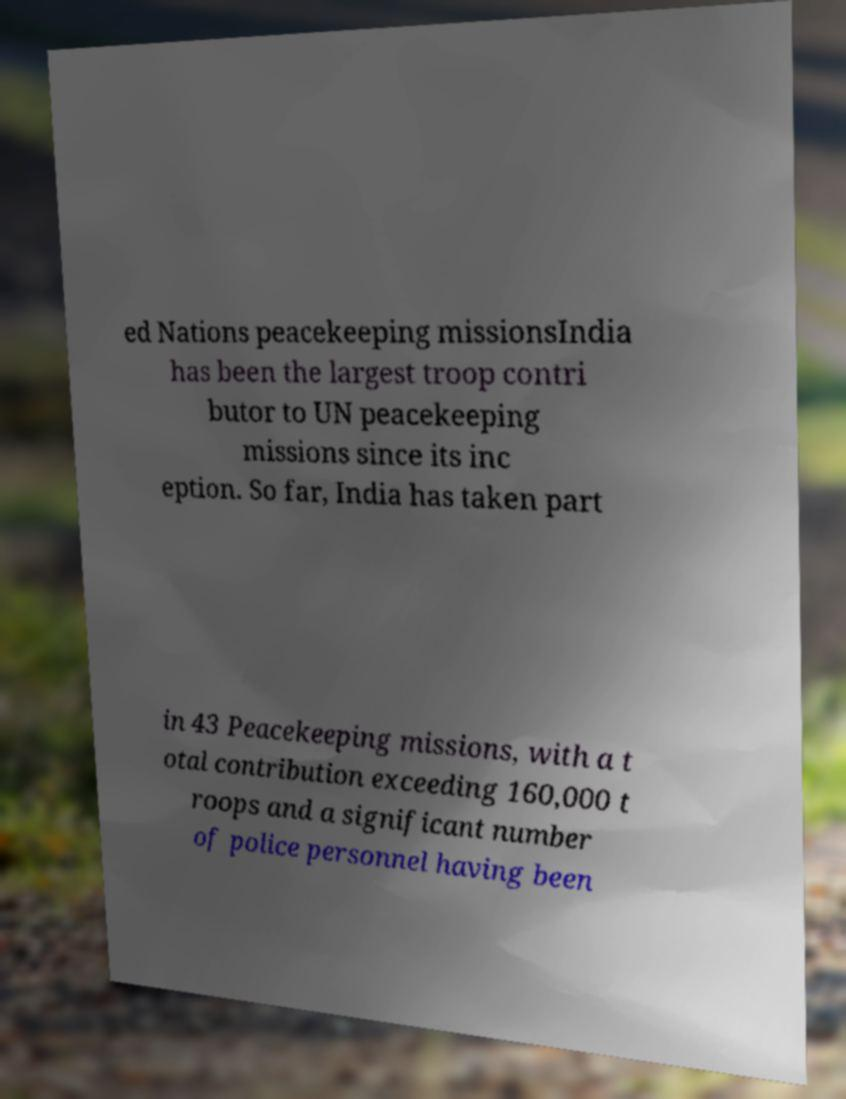What messages or text are displayed in this image? I need them in a readable, typed format. ed Nations peacekeeping missionsIndia has been the largest troop contri butor to UN peacekeeping missions since its inc eption. So far, India has taken part in 43 Peacekeeping missions, with a t otal contribution exceeding 160,000 t roops and a significant number of police personnel having been 